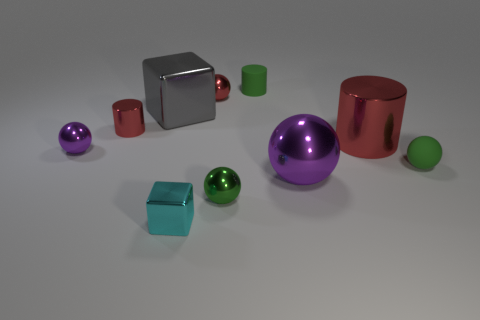What could be the purpose of these objects? These objects appear to be part of a visual composition, perhaps created to study reflections, lighting, and shadows in computer graphics. They could also be used as reference models in a CGI software to demonstrate different surface properties like matte or glossy textures. Do the objects interact with each other or the light in any specific way that stands out to you? Yes, the arrangement and surface properties of the objects produce interesting interactions with the light. The shiny objects, such as the cubes and spheres, have clear reflections and highlights, which demonstrate how light behaves when it strikes reflective surfaces. The matte objects have more diffused reflections, showing how light scatters across different material types. 